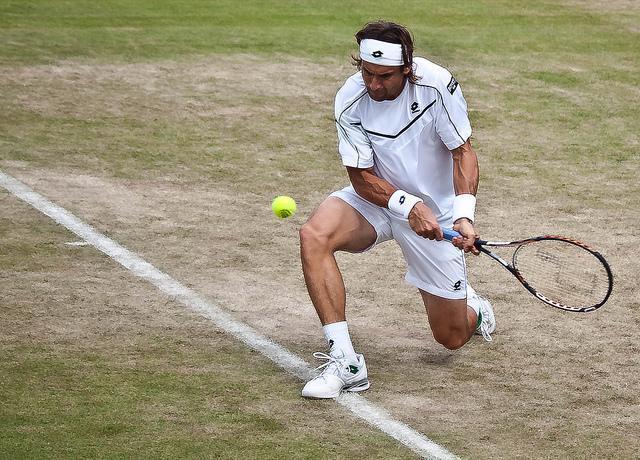How many glasses are full of orange juice?
Give a very brief answer. 0. 